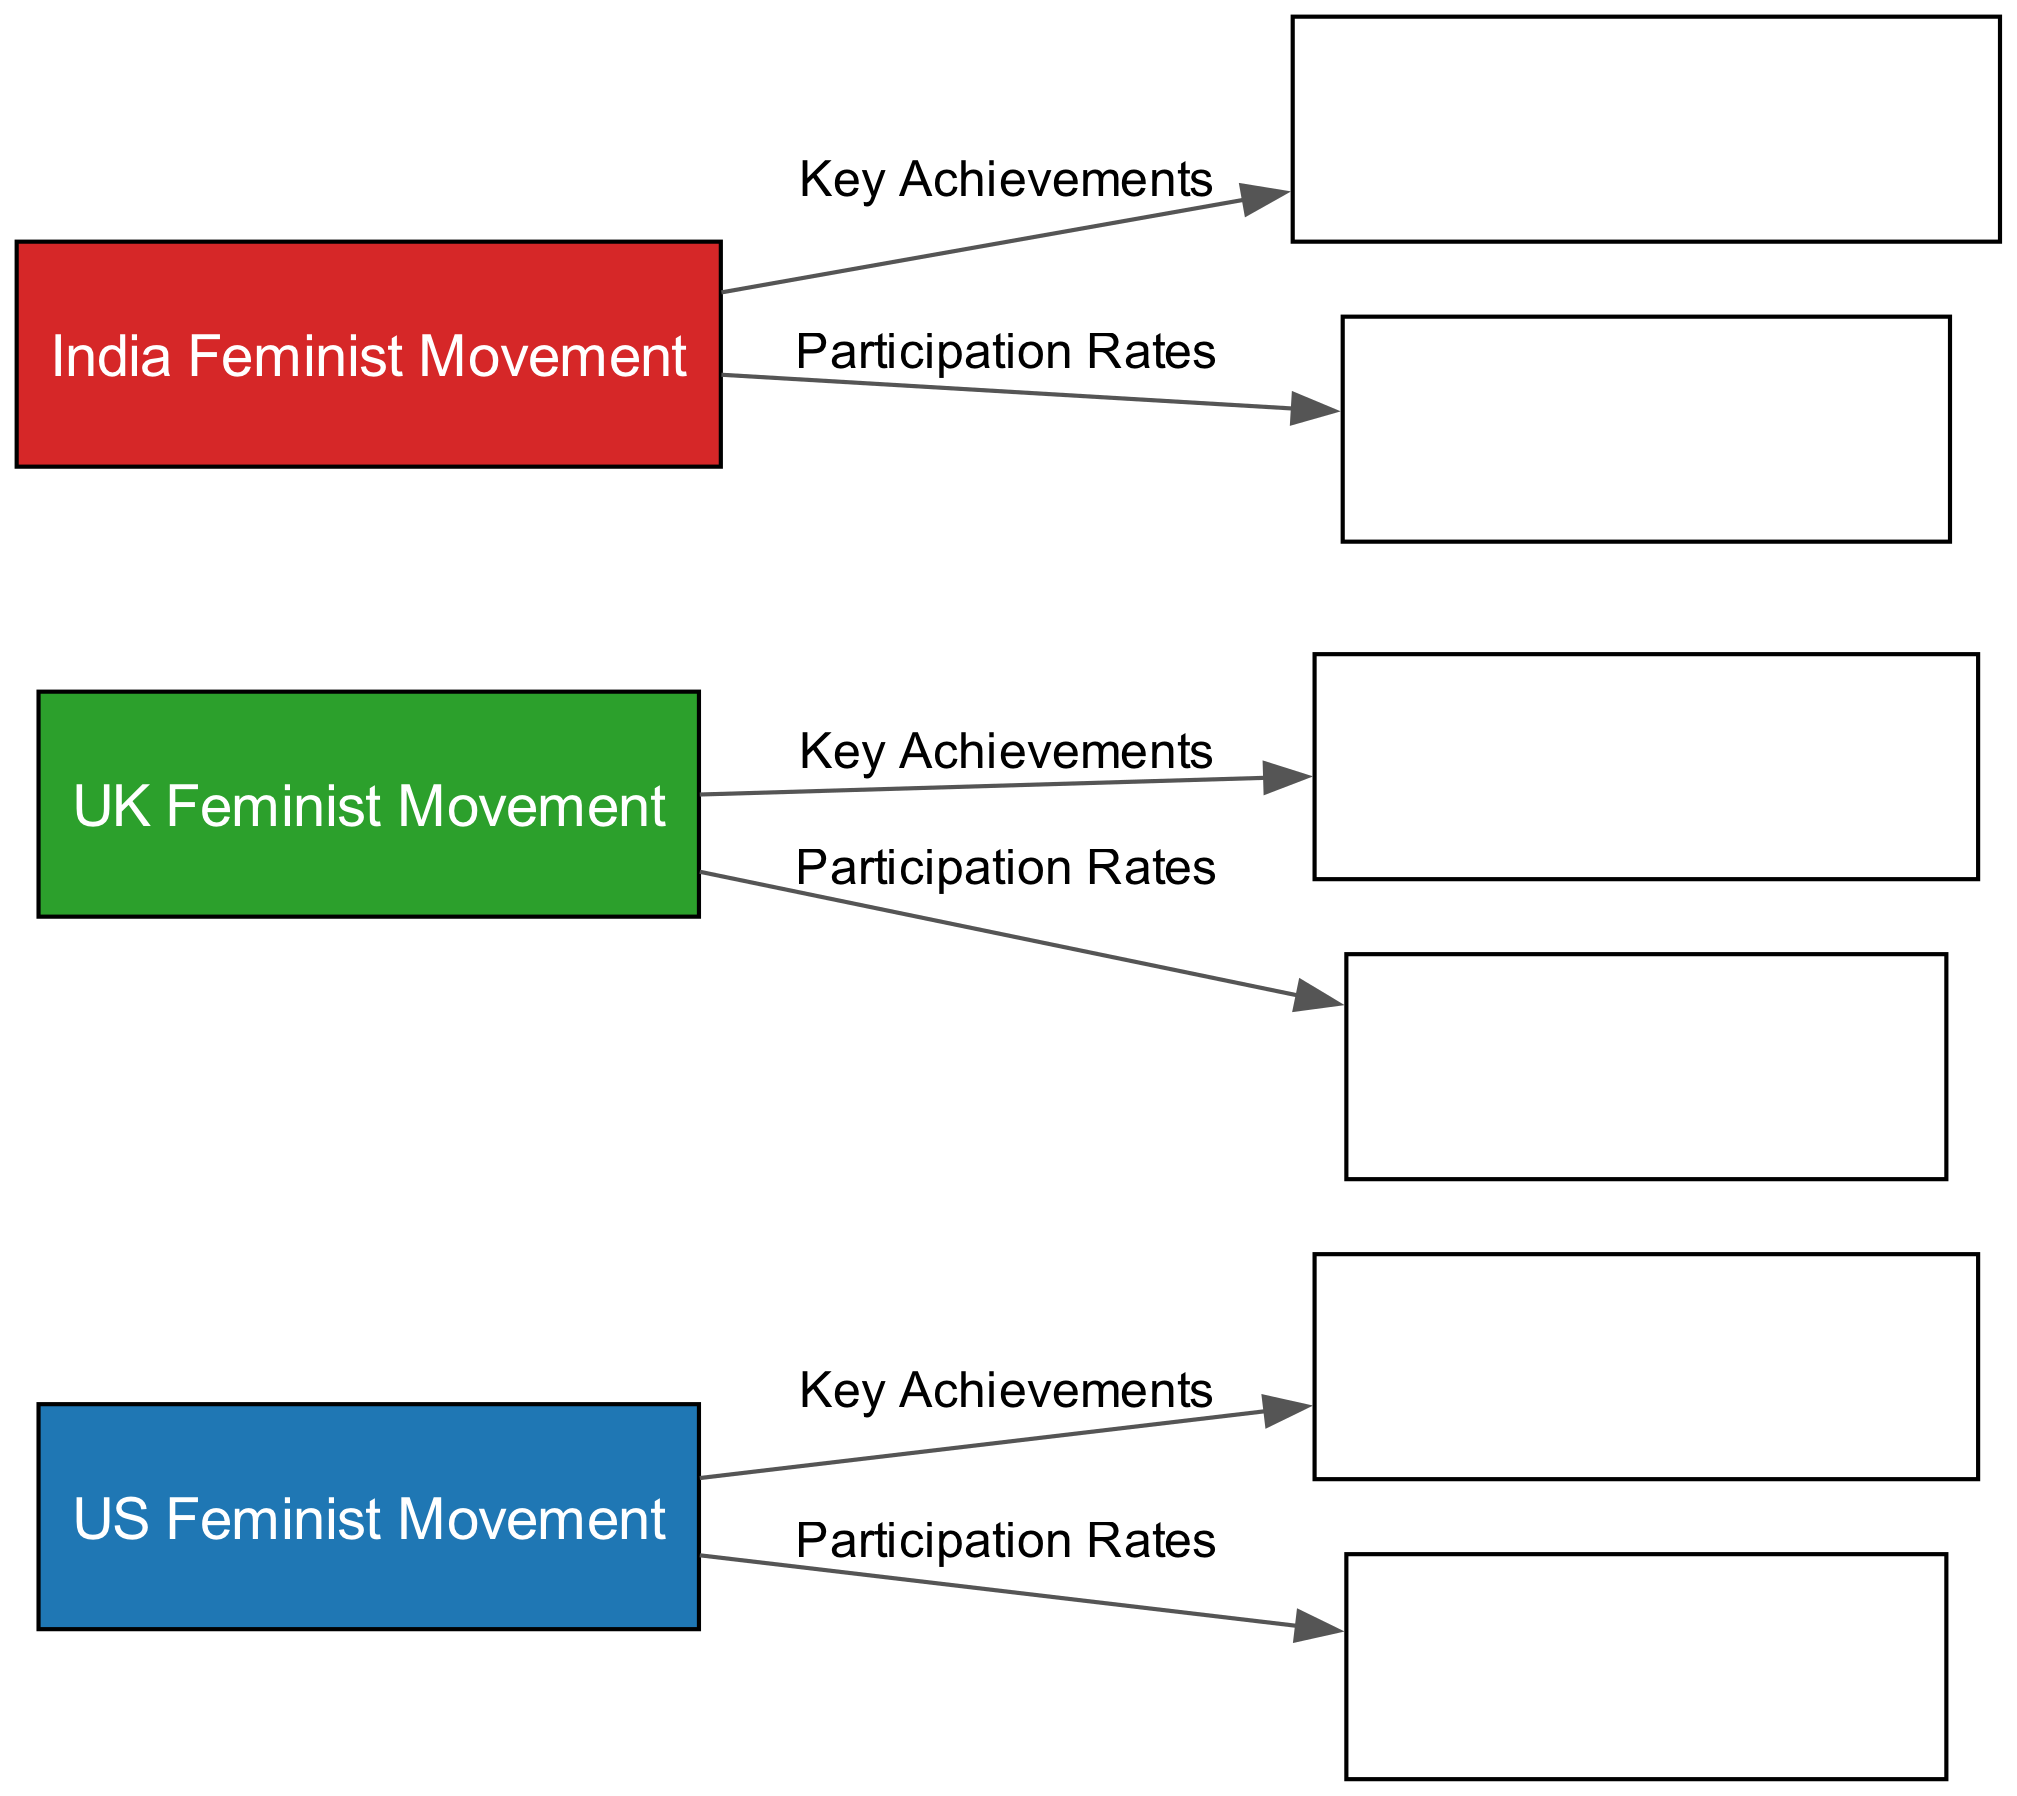what are the three feminist movements depicted in the diagram? The diagram includes nodes for the US Feminist Movement, UK Feminist Movement, and India Feminist Movement. These are clearly labeled, and since there are three nodes representing different feminist movements, the answer is straightforward.
Answer: US Feminist Movement, UK Feminist Movement, India Feminist Movement how many key achievements are listed for the UK Feminist Movement? The diagram connects the UK Feminist Movement node to the Key Achievements (UK) node with a labeled edge. Since there is only one edge connecting these specific nodes, we can deduce that there is one set of key achievements associated with the UK movement.
Answer: 1 which country has the highest participation rates according to the diagram? Participation rates are depicted by edges connecting each feminist movement node to its respective demographic node. By comparing the demographic nodes' labels, if one is visually larger or highlighted in a particular way, that indicates a higher participation rate. Without the diagram, it's reasonable to assume the US has higher visibility based on common cultural discourse.
Answer: US what is the relationship between the US Feminist Movement and Demographics (US)? The edge indicates a labeled connection between the US Feminist Movement and its demographics. This signifies that the demographic information is directly linked to the participation rates of the US Feminist Movement, highlighting how participation and movement dynamics are related.
Answer: Participation Rates name one key achievement connected to the India Feminist Movement in the diagram. The connection from the India Feminist Movement to the Key Achievements (India) node suggests that there is at least one key achievement associated with it. Without viewing the specific details, a notable achievement could be inferred from known historical context, implying that the name of the key achievement is likely listed in the designated node.
Answer: Changing laws how many total edges are present in the diagram? By counting the connections (or edges) illustrated in the diagram, which correspond to the relationships between movements and their achievements or demographics, we find a sum total. There are three feminist movements, each connected to achievements and participation metrics, resulting in a total of six edges.
Answer: 6 what color represents the UK Feminist Movement in the diagram? In the diagram, different countries have distinct color schemes for easy identification. The UK Feminist Movement is represented by green, based on the color key used within the diagram.
Answer: Green which two feminist movements are directly associated with demographic data? Each feminist movement node connects directly to its corresponding demographic node, therefore when examining the edges drawn, we observe that both the US and UK Feminist Movements are directly associated with demographic data based on their connections.
Answer: US Feminist Movement, UK Feminist Movement 